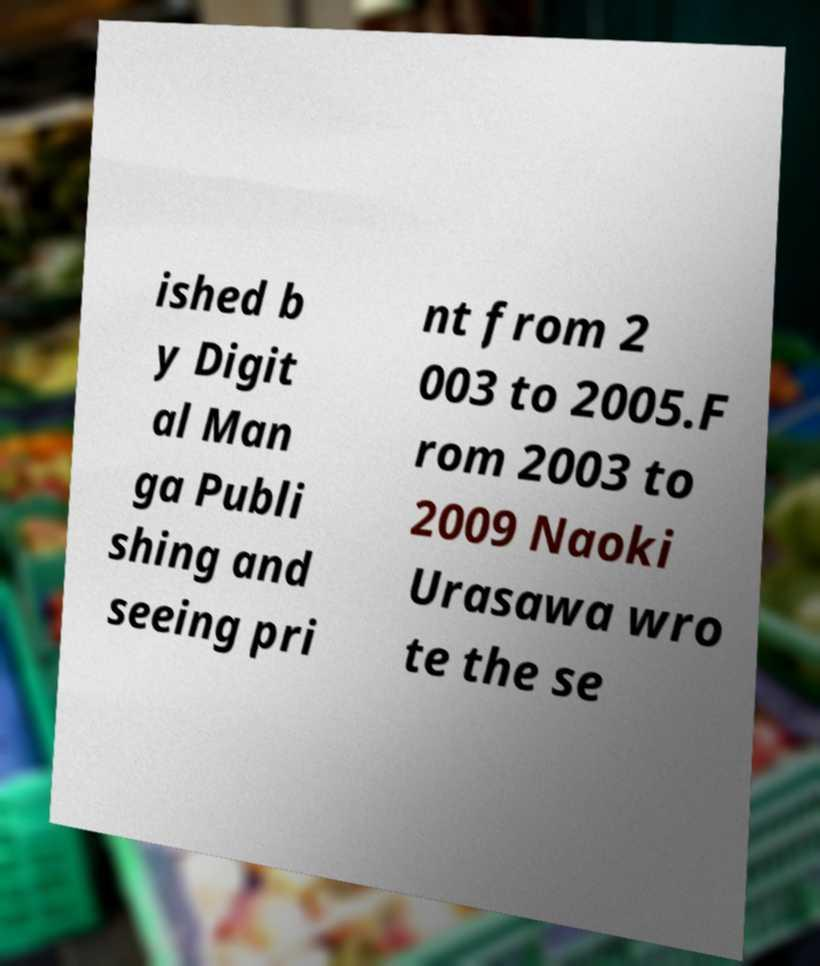Can you accurately transcribe the text from the provided image for me? ished b y Digit al Man ga Publi shing and seeing pri nt from 2 003 to 2005.F rom 2003 to 2009 Naoki Urasawa wro te the se 